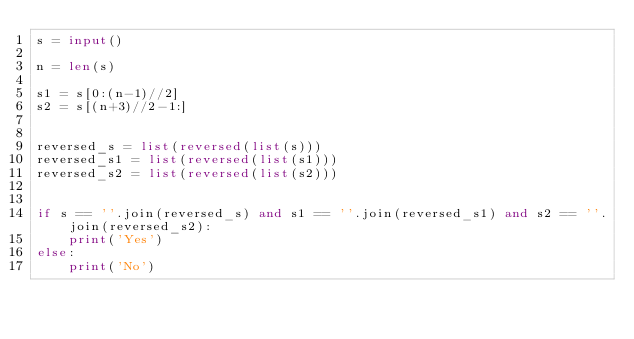<code> <loc_0><loc_0><loc_500><loc_500><_Python_>s = input()

n = len(s)

s1 = s[0:(n-1)//2]
s2 = s[(n+3)//2-1:]


reversed_s = list(reversed(list(s)))
reversed_s1 = list(reversed(list(s1)))
reversed_s2 = list(reversed(list(s2)))


if s == ''.join(reversed_s) and s1 == ''.join(reversed_s1) and s2 == ''.join(reversed_s2):
    print('Yes')
else:
    print('No')
</code> 